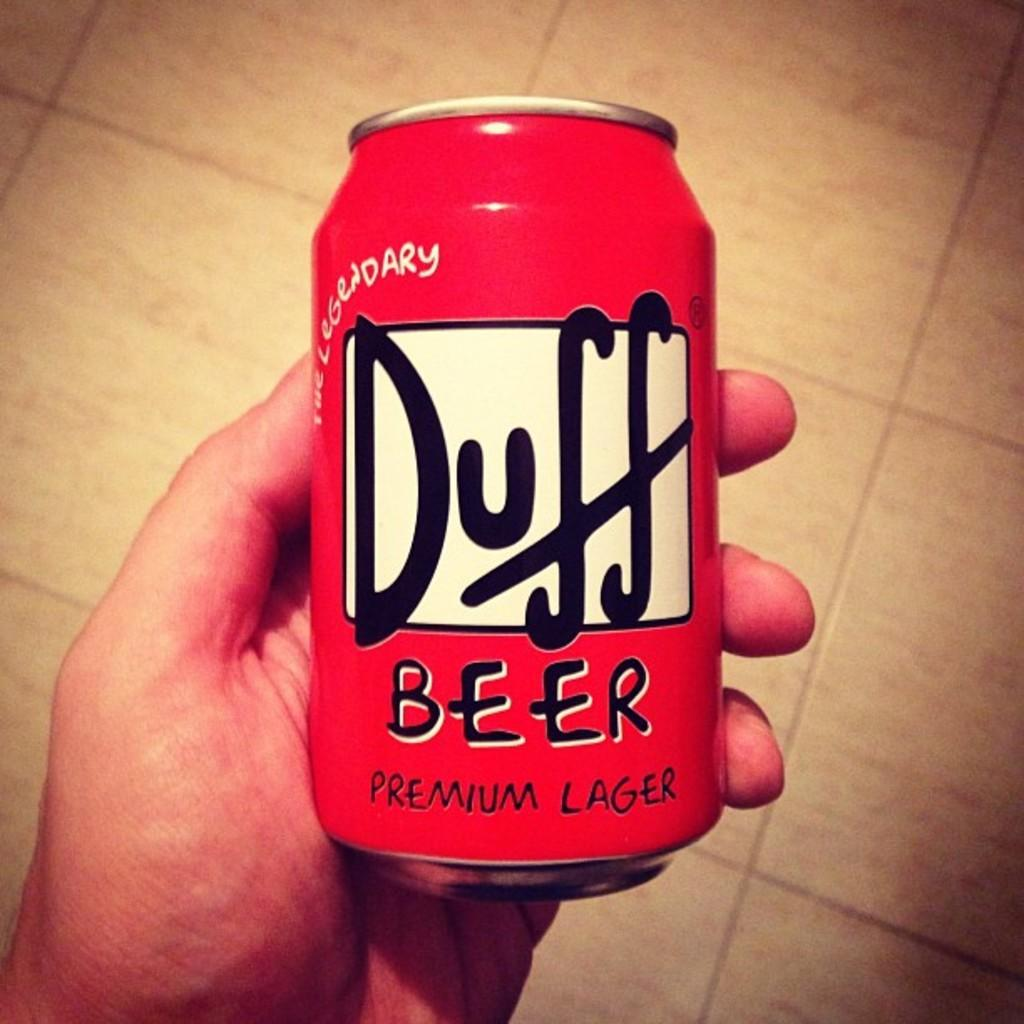<image>
Provide a brief description of the given image. A man holding a red can that says Duff Beer Premium Lager. 